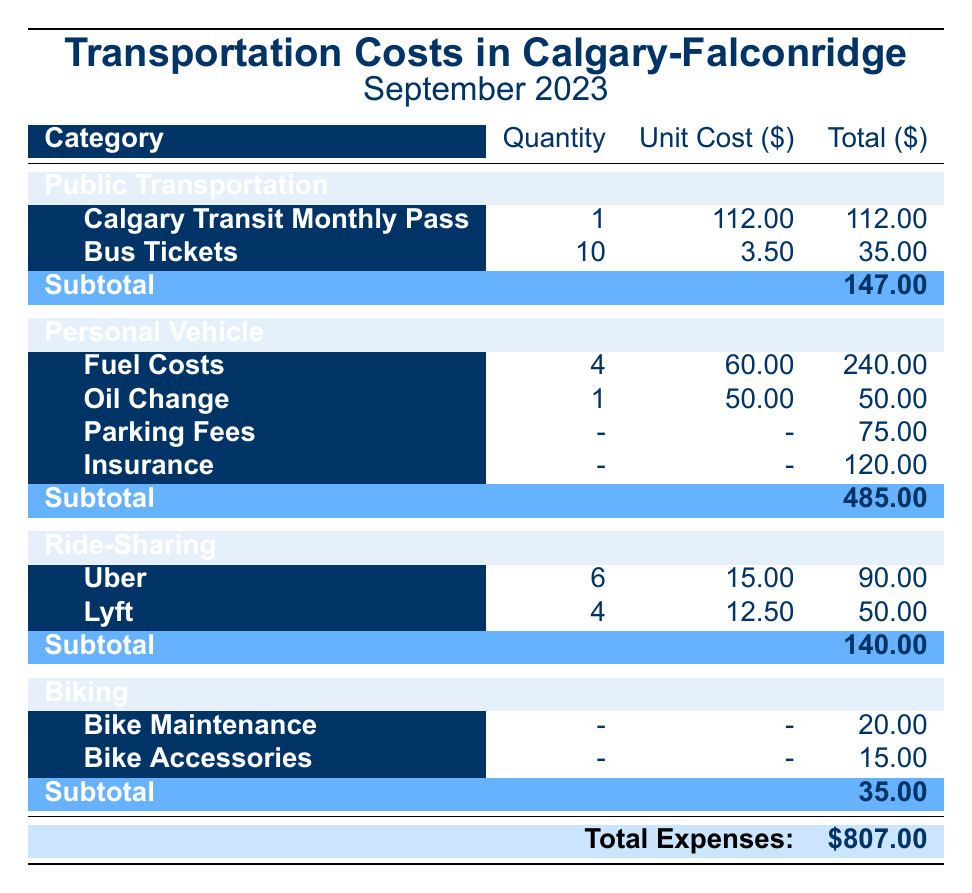What is the total spent on Personal Vehicle expenses? The subtotal for Personal Vehicle expenses is provided in the table, which is listed as 485.00.
Answer: 485.00 How much does a Calgary Transit Monthly Pass cost? The cost for a Calgary Transit Monthly Pass is shown directly in the Public Transportation section and is 112.00.
Answer: 112.00 What is the total cost for Ride-Sharing transportation? The subtotal for Ride-Sharing is given as 140.00 in the table.
Answer: 140.00 Are Parking Fees included in the total Personal Vehicle expenses? Yes, Parking Fees are listed under Personal Vehicle expenses and their cost is included in the subtotal of 485.00.
Answer: Yes What is the average cost of the expenses for Biking? The subtotal for Biking is 35.00 with two items (Bike Maintenance and Bike Accessories), so the average is calculated as 35.00 / 2 = 17.50.
Answer: 17.50 What is the total cost for all Transportation categories combined? The total expenses row at the bottom of the table shows the total cost, which is 807.00, summarizing the costs from all categories.
Answer: 807.00 How much more was spent on Personal Vehicle expenses compared to Biking expenses? The Personal Vehicle subtotal is 485.00 and Biking subtotal is 35.00. Subtracting these values gives: 485.00 - 35.00 = 450.00.
Answer: 450.00 Is the total for Public Transportation expenses higher than the total for Ride-Sharing expenses? Public Transportation subtotal is 147.00 and Ride-Sharing is 140.00. Since 147.00 is greater than 140.00, the statement is true.
Answer: Yes What percentage of the total expense is attributed to Public Transportation? Public Transportation subtotal is 147.00. To find the percentage, we calculate (147.00 / 807.00) * 100, which equals approximately 18.21%.
Answer: 18.21% 